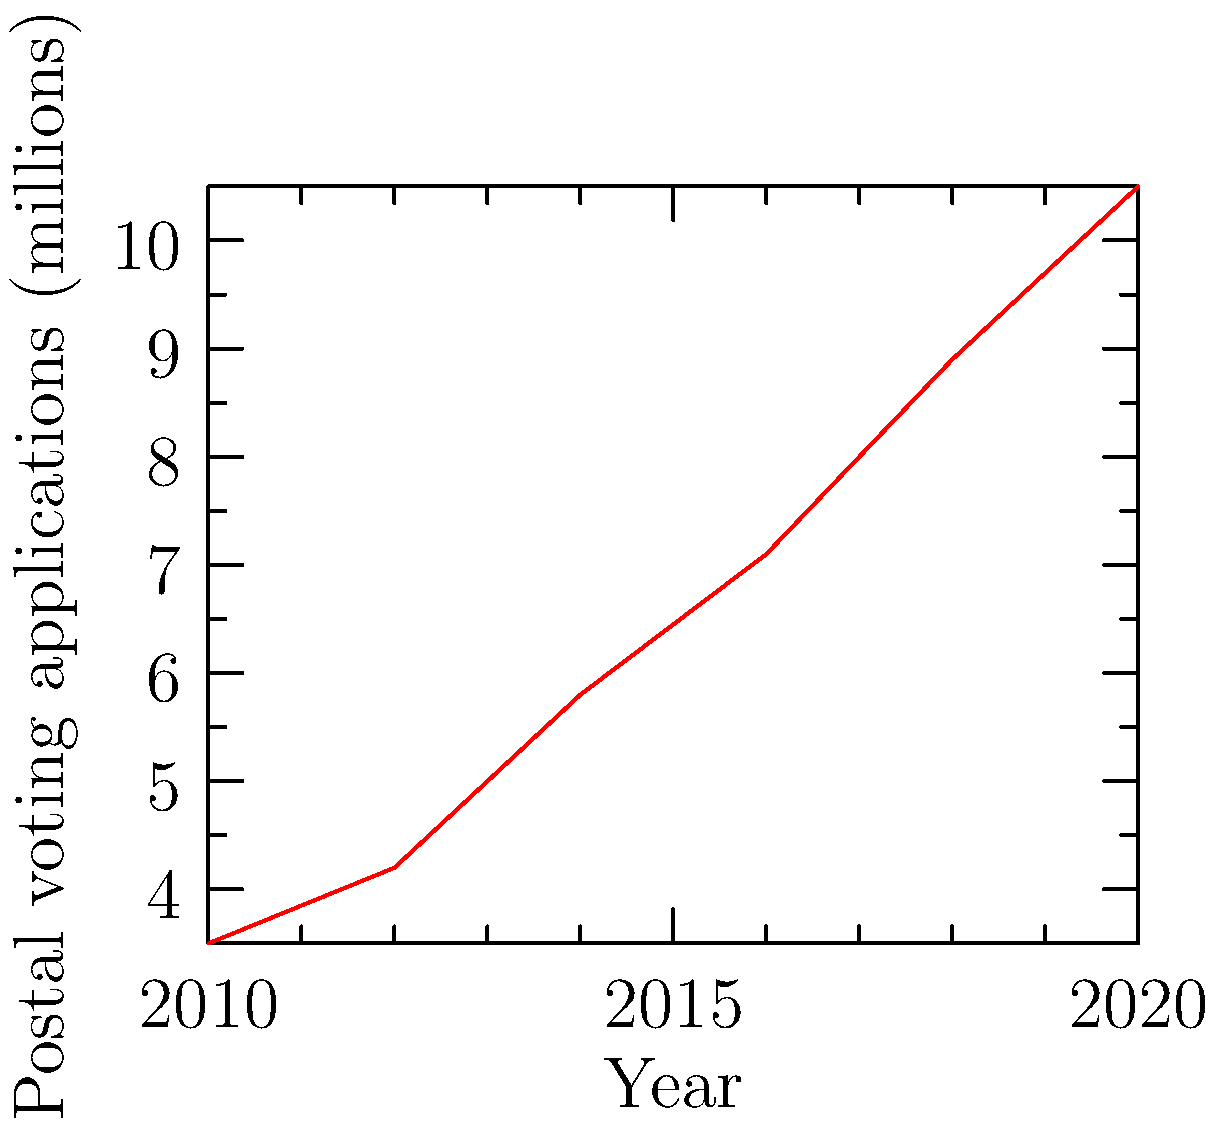Based on the line graph showing postal voting applications in the UK from 2010 to 2020, what was the approximate increase in applications between 2016 and 2020? To determine the increase in postal voting applications between 2016 and 2020:

1. Locate the value for 2016 on the graph: approximately 7.1 million
2. Locate the value for 2020 on the graph: approximately 10.5 million
3. Calculate the difference: 10.5 - 7.1 = 3.4 million

The increase in postal voting applications between 2016 and 2020 was approximately 3.4 million.
Answer: 3.4 million 